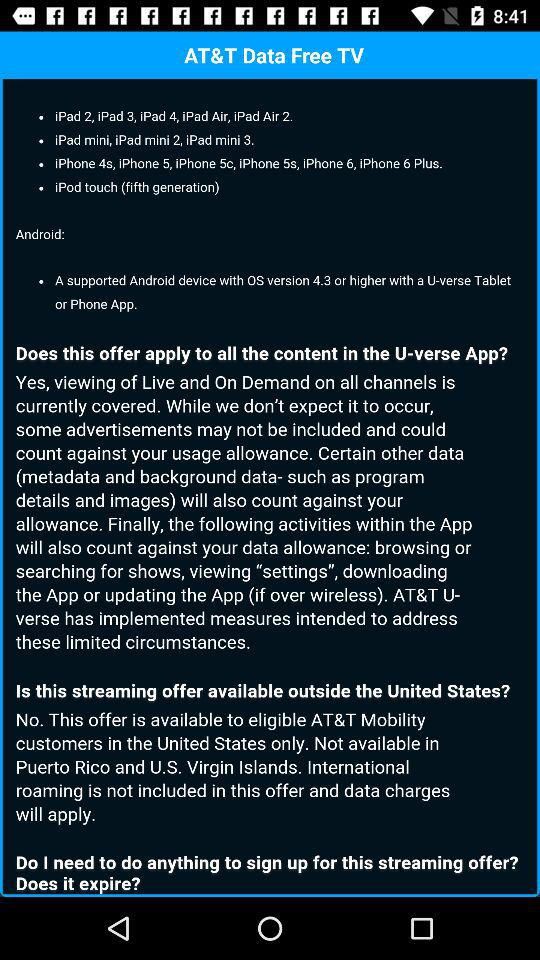How many iPhone are there?
When the provided information is insufficient, respond with <no answer>. <no answer> 